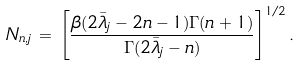<formula> <loc_0><loc_0><loc_500><loc_500>N _ { n , j } \, = \, \left [ \frac { \beta ( 2 \bar { \lambda } _ { j } - 2 n - 1 ) \Gamma { ( n + 1 ) } } { \Gamma { ( 2 \bar { \lambda } _ { j } - n ) } } \right ] ^ { 1 / 2 } .</formula> 